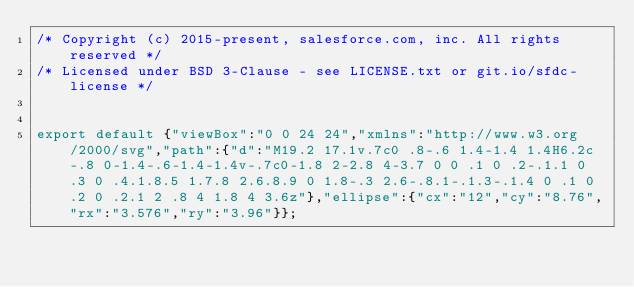Convert code to text. <code><loc_0><loc_0><loc_500><loc_500><_JavaScript_>/* Copyright (c) 2015-present, salesforce.com, inc. All rights reserved */
/* Licensed under BSD 3-Clause - see LICENSE.txt or git.io/sfdc-license */


export default {"viewBox":"0 0 24 24","xmlns":"http://www.w3.org/2000/svg","path":{"d":"M19.2 17.1v.7c0 .8-.6 1.4-1.4 1.4H6.2c-.8 0-1.4-.6-1.4-1.4v-.7c0-1.8 2-2.8 4-3.7 0 0 .1 0 .2-.1.1 0 .3 0 .4.1.8.5 1.7.8 2.6.8.9 0 1.8-.3 2.6-.8.1-.1.3-.1.4 0 .1 0 .2 0 .2.1 2 .8 4 1.8 4 3.6z"},"ellipse":{"cx":"12","cy":"8.76","rx":"3.576","ry":"3.96"}};
</code> 